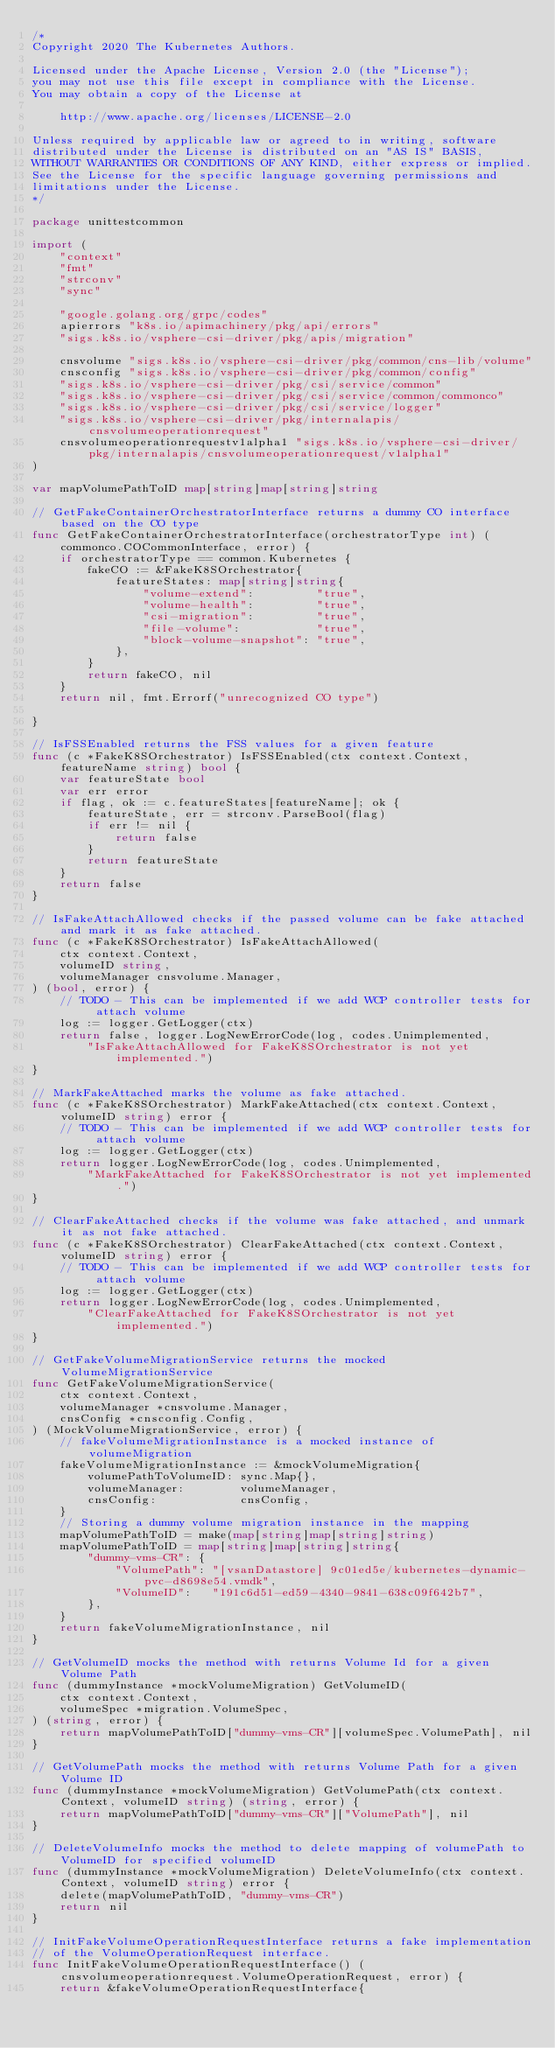Convert code to text. <code><loc_0><loc_0><loc_500><loc_500><_Go_>/*
Copyright 2020 The Kubernetes Authors.

Licensed under the Apache License, Version 2.0 (the "License");
you may not use this file except in compliance with the License.
You may obtain a copy of the License at

    http://www.apache.org/licenses/LICENSE-2.0

Unless required by applicable law or agreed to in writing, software
distributed under the License is distributed on an "AS IS" BASIS,
WITHOUT WARRANTIES OR CONDITIONS OF ANY KIND, either express or implied.
See the License for the specific language governing permissions and
limitations under the License.
*/

package unittestcommon

import (
	"context"
	"fmt"
	"strconv"
	"sync"

	"google.golang.org/grpc/codes"
	apierrors "k8s.io/apimachinery/pkg/api/errors"
	"sigs.k8s.io/vsphere-csi-driver/pkg/apis/migration"

	cnsvolume "sigs.k8s.io/vsphere-csi-driver/pkg/common/cns-lib/volume"
	cnsconfig "sigs.k8s.io/vsphere-csi-driver/pkg/common/config"
	"sigs.k8s.io/vsphere-csi-driver/pkg/csi/service/common"
	"sigs.k8s.io/vsphere-csi-driver/pkg/csi/service/common/commonco"
	"sigs.k8s.io/vsphere-csi-driver/pkg/csi/service/logger"
	"sigs.k8s.io/vsphere-csi-driver/pkg/internalapis/cnsvolumeoperationrequest"
	cnsvolumeoperationrequestv1alpha1 "sigs.k8s.io/vsphere-csi-driver/pkg/internalapis/cnsvolumeoperationrequest/v1alpha1"
)

var mapVolumePathToID map[string]map[string]string

// GetFakeContainerOrchestratorInterface returns a dummy CO interface based on the CO type
func GetFakeContainerOrchestratorInterface(orchestratorType int) (commonco.COCommonInterface, error) {
	if orchestratorType == common.Kubernetes {
		fakeCO := &FakeK8SOrchestrator{
			featureStates: map[string]string{
				"volume-extend":         "true",
				"volume-health":         "true",
				"csi-migration":         "true",
				"file-volume":           "true",
				"block-volume-snapshot": "true",
			},
		}
		return fakeCO, nil
	}
	return nil, fmt.Errorf("unrecognized CO type")

}

// IsFSSEnabled returns the FSS values for a given feature
func (c *FakeK8SOrchestrator) IsFSSEnabled(ctx context.Context, featureName string) bool {
	var featureState bool
	var err error
	if flag, ok := c.featureStates[featureName]; ok {
		featureState, err = strconv.ParseBool(flag)
		if err != nil {
			return false
		}
		return featureState
	}
	return false
}

// IsFakeAttachAllowed checks if the passed volume can be fake attached and mark it as fake attached.
func (c *FakeK8SOrchestrator) IsFakeAttachAllowed(
	ctx context.Context,
	volumeID string,
	volumeManager cnsvolume.Manager,
) (bool, error) {
	// TODO - This can be implemented if we add WCP controller tests for attach volume
	log := logger.GetLogger(ctx)
	return false, logger.LogNewErrorCode(log, codes.Unimplemented,
		"IsFakeAttachAllowed for FakeK8SOrchestrator is not yet implemented.")
}

// MarkFakeAttached marks the volume as fake attached.
func (c *FakeK8SOrchestrator) MarkFakeAttached(ctx context.Context, volumeID string) error {
	// TODO - This can be implemented if we add WCP controller tests for attach volume
	log := logger.GetLogger(ctx)
	return logger.LogNewErrorCode(log, codes.Unimplemented,
		"MarkFakeAttached for FakeK8SOrchestrator is not yet implemented.")
}

// ClearFakeAttached checks if the volume was fake attached, and unmark it as not fake attached.
func (c *FakeK8SOrchestrator) ClearFakeAttached(ctx context.Context, volumeID string) error {
	// TODO - This can be implemented if we add WCP controller tests for attach volume
	log := logger.GetLogger(ctx)
	return logger.LogNewErrorCode(log, codes.Unimplemented,
		"ClearFakeAttached for FakeK8SOrchestrator is not yet implemented.")
}

// GetFakeVolumeMigrationService returns the mocked VolumeMigrationService
func GetFakeVolumeMigrationService(
	ctx context.Context,
	volumeManager *cnsvolume.Manager,
	cnsConfig *cnsconfig.Config,
) (MockVolumeMigrationService, error) {
	// fakeVolumeMigrationInstance is a mocked instance of volumeMigration
	fakeVolumeMigrationInstance := &mockVolumeMigration{
		volumePathToVolumeID: sync.Map{},
		volumeManager:        volumeManager,
		cnsConfig:            cnsConfig,
	}
	// Storing a dummy volume migration instance in the mapping
	mapVolumePathToID = make(map[string]map[string]string)
	mapVolumePathToID = map[string]map[string]string{
		"dummy-vms-CR": {
			"VolumePath": "[vsanDatastore] 9c01ed5e/kubernetes-dynamic-pvc-d8698e54.vmdk",
			"VolumeID":   "191c6d51-ed59-4340-9841-638c09f642b7",
		},
	}
	return fakeVolumeMigrationInstance, nil
}

// GetVolumeID mocks the method with returns Volume Id for a given Volume Path
func (dummyInstance *mockVolumeMigration) GetVolumeID(
	ctx context.Context,
	volumeSpec *migration.VolumeSpec,
) (string, error) {
	return mapVolumePathToID["dummy-vms-CR"][volumeSpec.VolumePath], nil
}

// GetVolumePath mocks the method with returns Volume Path for a given Volume ID
func (dummyInstance *mockVolumeMigration) GetVolumePath(ctx context.Context, volumeID string) (string, error) {
	return mapVolumePathToID["dummy-vms-CR"]["VolumePath"], nil
}

// DeleteVolumeInfo mocks the method to delete mapping of volumePath to VolumeID for specified volumeID
func (dummyInstance *mockVolumeMigration) DeleteVolumeInfo(ctx context.Context, volumeID string) error {
	delete(mapVolumePathToID, "dummy-vms-CR")
	return nil
}

// InitFakeVolumeOperationRequestInterface returns a fake implementation
// of the VolumeOperationRequest interface.
func InitFakeVolumeOperationRequestInterface() (cnsvolumeoperationrequest.VolumeOperationRequest, error) {
	return &fakeVolumeOperationRequestInterface{</code> 